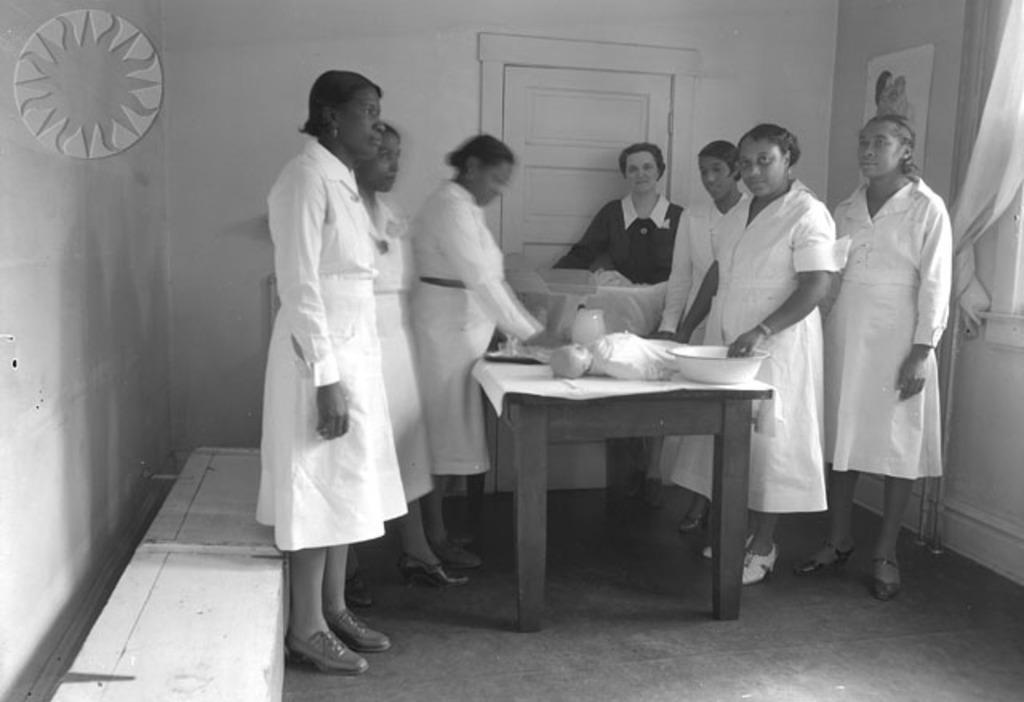Could you give a brief overview of what you see in this image? In this picture there are several ladies with white coats and a lady with a black coat. There are examining the objects which are kept on the table. In the background we also observe a sun shaped circular disc. There is also a door in the background and a curtain. 